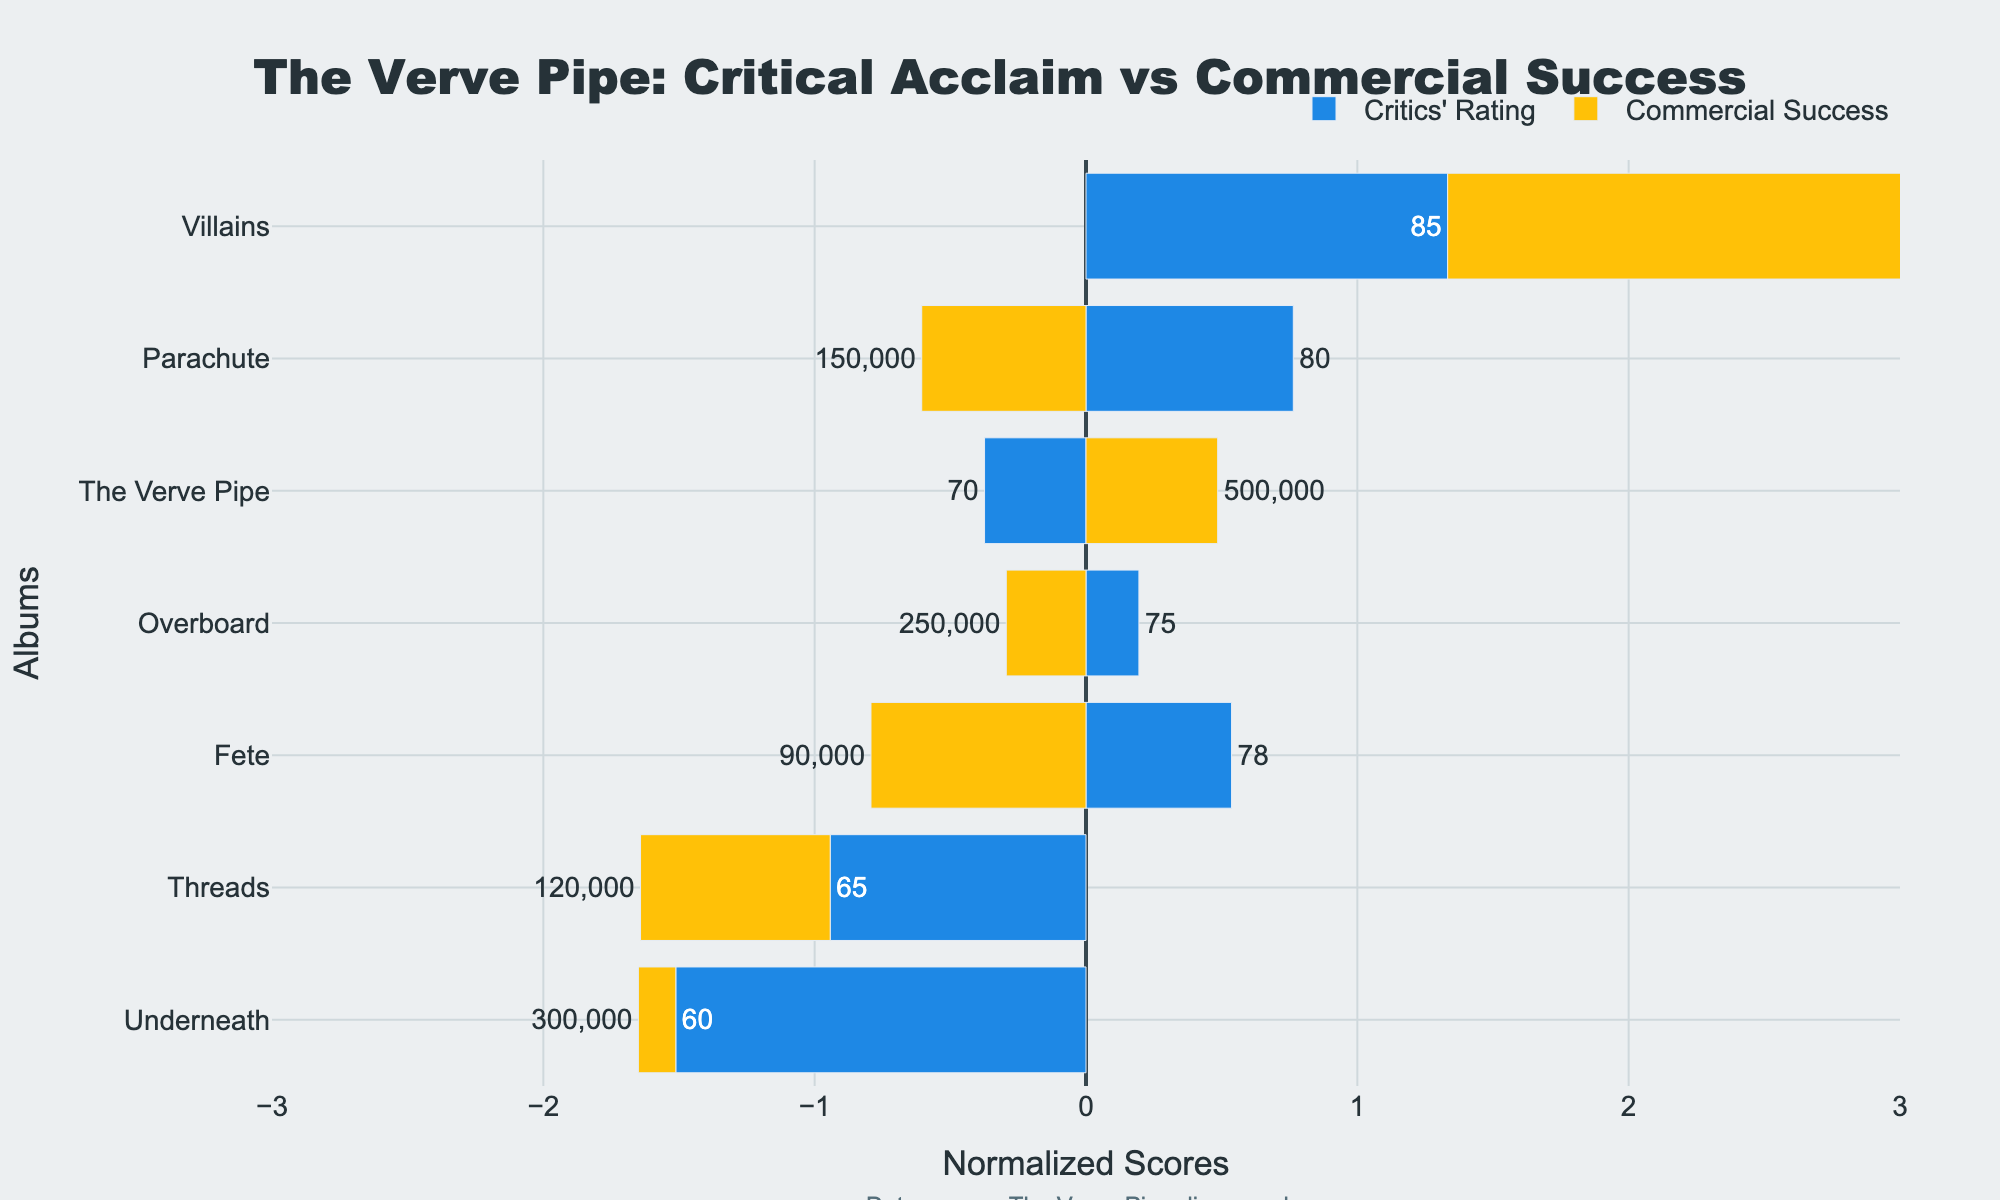Which album has the highest critics' rating? To find the album with the highest critics' rating, look at the bars labeled for Critics' Rating and see which one has the longest bar in that category.
Answer: "Villains" Which album had more commercial success: "The Verve Pipe" or "Underneath"? Compare the lengths of the Commercial Success bars for "The Verve Pipe" and "Underneath". The longer bar indicates greater success.
Answer: "The Verve Pipe" Which album has both above-average critics' rating and above-average commercial success? Identify bars for both Critics' Rating and Commercial Success that extend to the right (positive side) of the zero line. Both criteria must be met.
Answer: "Villains" What is the difference in normalized critics' rating between "Threads" and "Overboard"? Subtract the normalized critics' rating of "Threads" from that of "Overboard" based on their positions relative to the zero line.
Answer: 0.5 Which albums have critics' ratings below average but commercial success above average? Look for bars that extend to the left for Critics' Rating and to the right for Commercial Success.
Answer: None How much higher is the normalized commercial success of "Villains" compared to "Parachute"? Subtract the normalized commercial success of "Parachute" from that of "Villains" by comparing their lengths.
Answer: Approximately 2.3 What is the median critics' rating for The Verve Pipe's albums? Order the critics' ratings (60, 65, 70, 75, 78, 80, 85) and find the middle value.
Answer: 75 